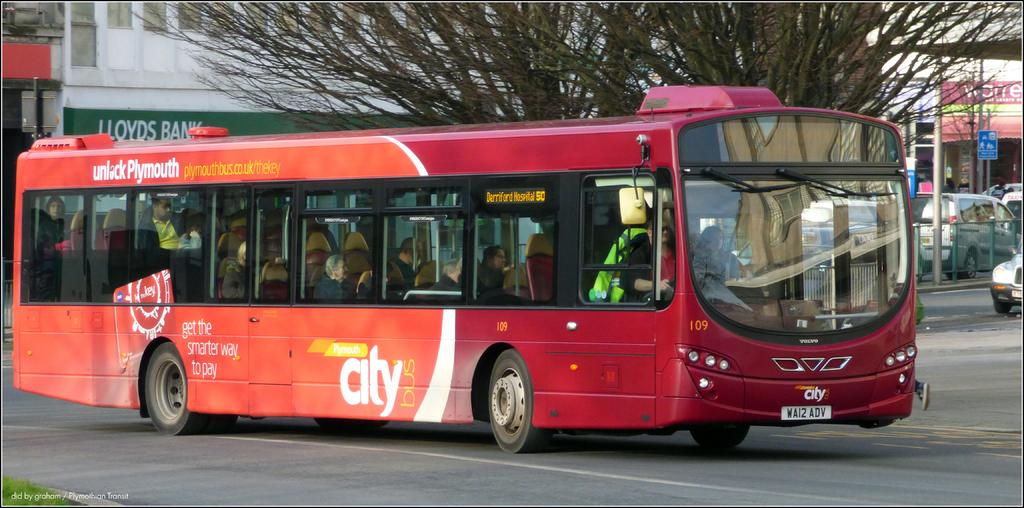<image>
Offer a succinct explanation of the picture presented. A red Plymouth city bus drives down the road. 